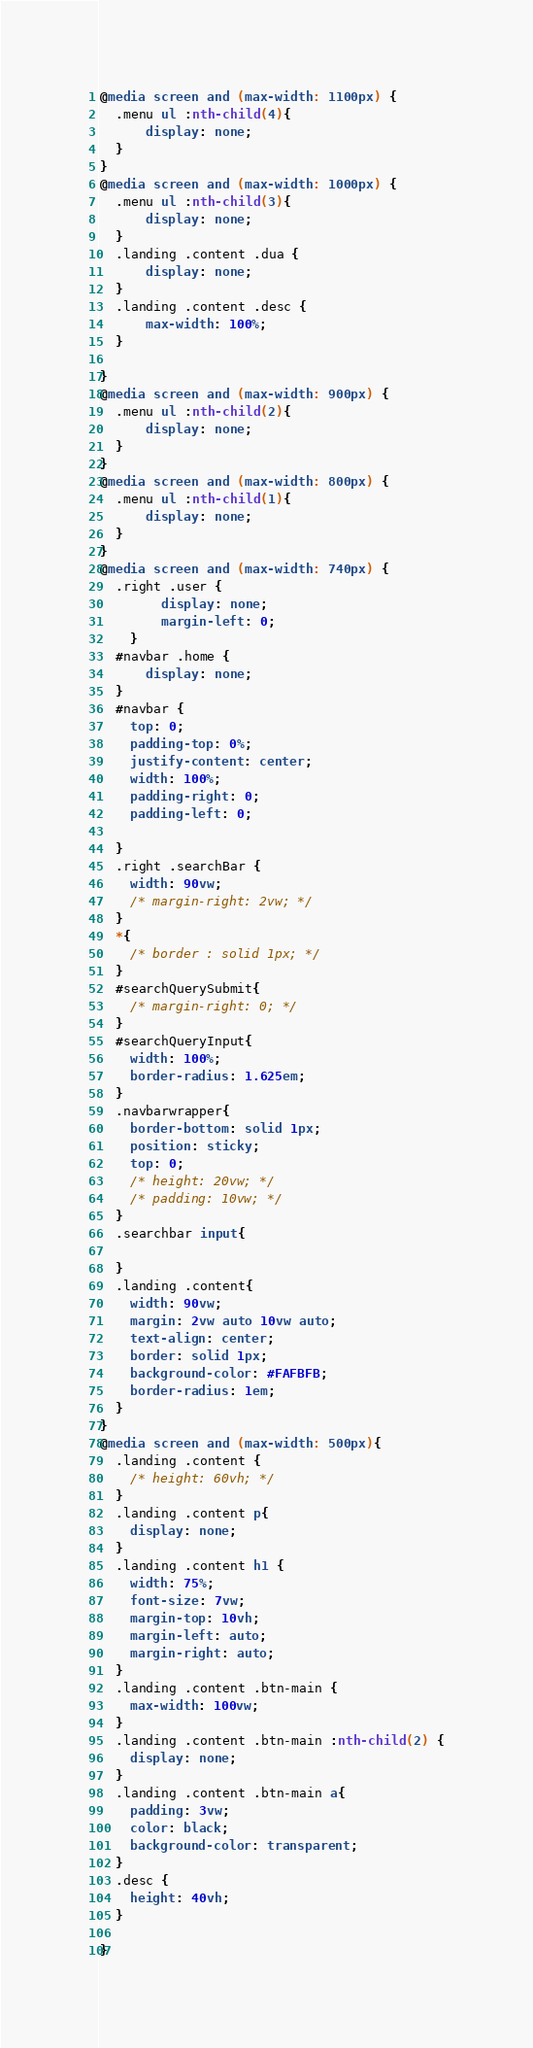Convert code to text. <code><loc_0><loc_0><loc_500><loc_500><_CSS_>@media screen and (max-width: 1100px) {
  .menu ul :nth-child(4){
      display: none;
  }
}
@media screen and (max-width: 1000px) {
  .menu ul :nth-child(3){
      display: none;
  }
  .landing .content .dua {
      display: none;
  }
  .landing .content .desc {
      max-width: 100%;
  }

}
@media screen and (max-width: 900px) {
  .menu ul :nth-child(2){
      display: none;
  }
}
@media screen and (max-width: 800px) {
  .menu ul :nth-child(1){
      display: none;
  }
}
@media screen and (max-width: 740px) {
  .right .user {
        display: none;
        margin-left: 0;
    }
  #navbar .home {
      display: none;
  }
  #navbar {
    top: 0;
    padding-top: 0%;
    justify-content: center;
    width: 100%;
    padding-right: 0;
    padding-left: 0;

  }
  .right .searchBar {
    width: 90vw;
    /* margin-right: 2vw; */
  }
  *{
    /* border : solid 1px; */
  }
  #searchQuerySubmit{
    /* margin-right: 0; */
  }
  #searchQueryInput{
    width: 100%;
    border-radius: 1.625em;
  }
  .navbarwrapper{
    border-bottom: solid 1px;
    position: sticky;
    top: 0;
    /* height: 20vw; */
    /* padding: 10vw; */
  }
  .searchbar input{
    
  }
  .landing .content{
    width: 90vw;
    margin: 2vw auto 10vw auto;
    text-align: center;
    border: solid 1px;
    background-color: #FAFBFB;
    border-radius: 1em;
  }
}
@media screen and (max-width: 500px){
  .landing .content {
    /* height: 60vh; */
  }
  .landing .content p{
    display: none;
  }
  .landing .content h1 {
    width: 75%;
    font-size: 7vw;
    margin-top: 10vh;
    margin-left: auto;
    margin-right: auto;
  }
  .landing .content .btn-main {
    max-width: 100vw;
  }
  .landing .content .btn-main :nth-child(2) {
    display: none;
  }
  .landing .content .btn-main a{
    padding: 3vw;
    color: black;
    background-color: transparent;
  }
  .desc {
    height: 40vh;
  }

}

</code> 